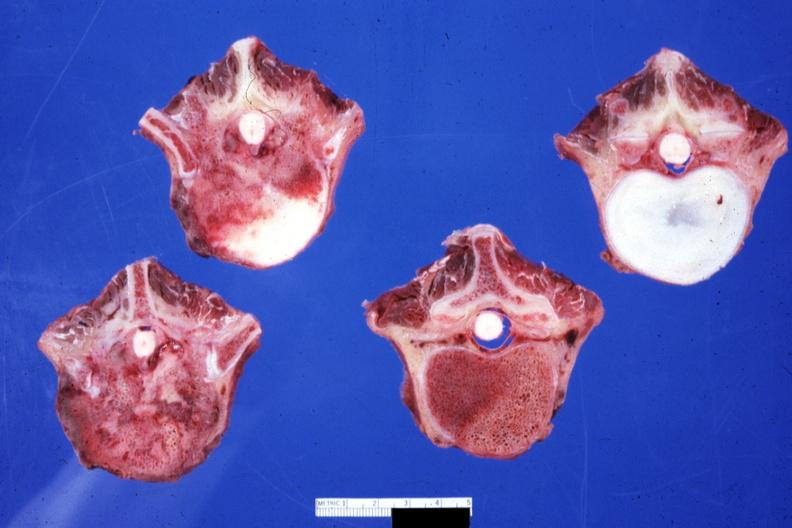what does this image show?
Answer the question using a single word or phrase. Obvious metastatic lesions primary in mediastinum 20yowm 